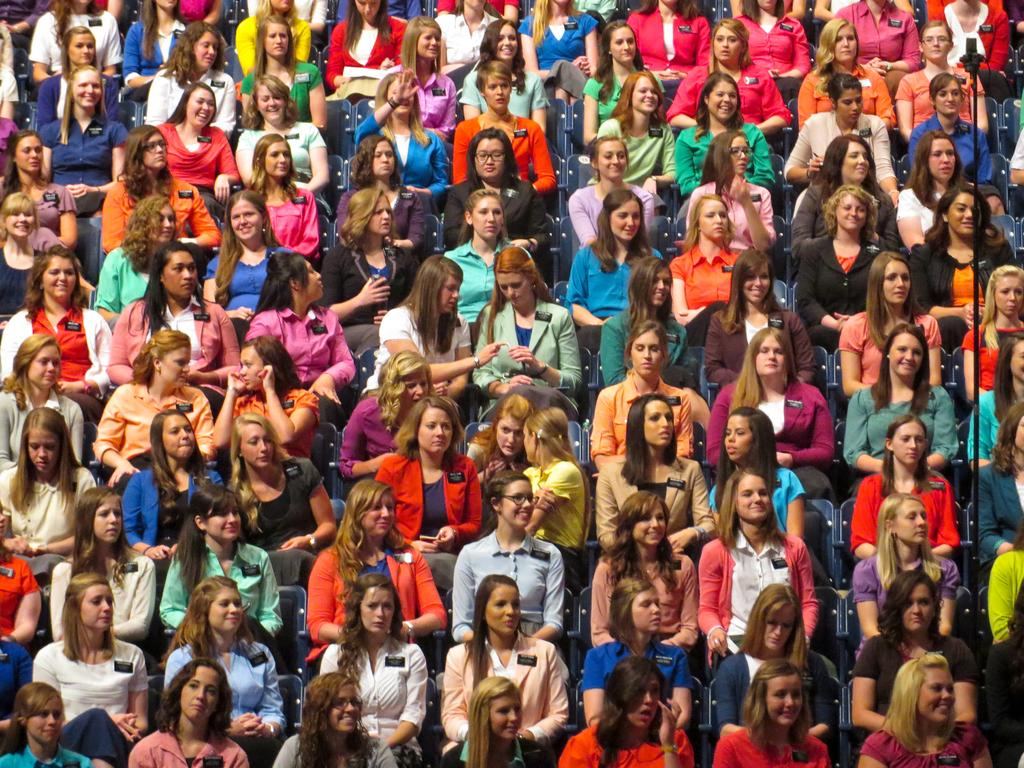Who is present in the image? There are women in the image. What are the women doing in the image? The women are sitting in chairs. What can be seen on the women's clothing? The women are wearing badges. What type of transport is visible in the image? There is no transport visible in the image; it only features women sitting in chairs and wearing badges. 